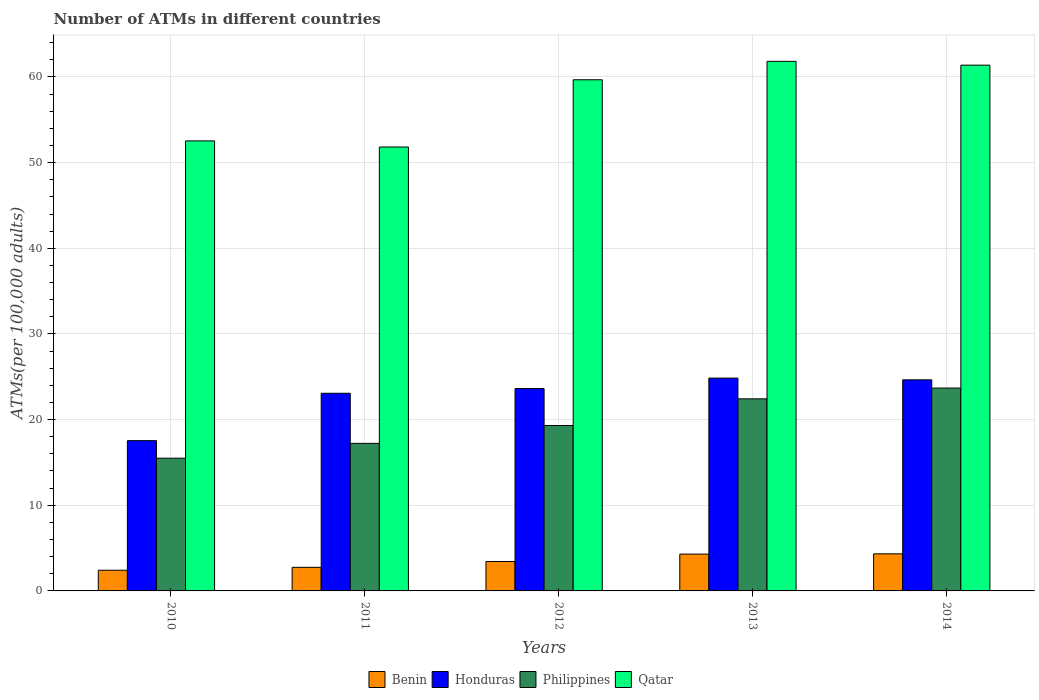How many different coloured bars are there?
Your answer should be very brief. 4. How many groups of bars are there?
Your answer should be very brief. 5. Are the number of bars per tick equal to the number of legend labels?
Give a very brief answer. Yes. How many bars are there on the 3rd tick from the right?
Make the answer very short. 4. What is the label of the 1st group of bars from the left?
Give a very brief answer. 2010. What is the number of ATMs in Honduras in 2011?
Provide a short and direct response. 23.07. Across all years, what is the maximum number of ATMs in Qatar?
Make the answer very short. 61.82. Across all years, what is the minimum number of ATMs in Benin?
Your answer should be compact. 2.42. In which year was the number of ATMs in Qatar maximum?
Your answer should be very brief. 2013. What is the total number of ATMs in Qatar in the graph?
Provide a succinct answer. 287.22. What is the difference between the number of ATMs in Benin in 2010 and that in 2013?
Offer a terse response. -1.88. What is the difference between the number of ATMs in Qatar in 2014 and the number of ATMs in Philippines in 2013?
Provide a short and direct response. 38.95. What is the average number of ATMs in Qatar per year?
Ensure brevity in your answer.  57.44. In the year 2010, what is the difference between the number of ATMs in Qatar and number of ATMs in Honduras?
Your response must be concise. 34.99. In how many years, is the number of ATMs in Honduras greater than 10?
Give a very brief answer. 5. What is the ratio of the number of ATMs in Qatar in 2010 to that in 2013?
Offer a very short reply. 0.85. What is the difference between the highest and the second highest number of ATMs in Honduras?
Provide a succinct answer. 0.2. What is the difference between the highest and the lowest number of ATMs in Honduras?
Ensure brevity in your answer.  7.3. What does the 1st bar from the left in 2012 represents?
Provide a short and direct response. Benin. What does the 1st bar from the right in 2014 represents?
Offer a very short reply. Qatar. Is it the case that in every year, the sum of the number of ATMs in Honduras and number of ATMs in Qatar is greater than the number of ATMs in Benin?
Offer a very short reply. Yes. How many bars are there?
Provide a short and direct response. 20. How many years are there in the graph?
Ensure brevity in your answer.  5. Are the values on the major ticks of Y-axis written in scientific E-notation?
Make the answer very short. No. Does the graph contain grids?
Offer a very short reply. Yes. Where does the legend appear in the graph?
Offer a terse response. Bottom center. What is the title of the graph?
Your answer should be compact. Number of ATMs in different countries. Does "Mali" appear as one of the legend labels in the graph?
Make the answer very short. No. What is the label or title of the X-axis?
Your answer should be compact. Years. What is the label or title of the Y-axis?
Your answer should be very brief. ATMs(per 100,0 adults). What is the ATMs(per 100,000 adults) in Benin in 2010?
Offer a very short reply. 2.42. What is the ATMs(per 100,000 adults) in Honduras in 2010?
Make the answer very short. 17.54. What is the ATMs(per 100,000 adults) of Philippines in 2010?
Your answer should be compact. 15.49. What is the ATMs(per 100,000 adults) in Qatar in 2010?
Give a very brief answer. 52.53. What is the ATMs(per 100,000 adults) in Benin in 2011?
Give a very brief answer. 2.75. What is the ATMs(per 100,000 adults) in Honduras in 2011?
Offer a very short reply. 23.07. What is the ATMs(per 100,000 adults) in Philippines in 2011?
Provide a succinct answer. 17.23. What is the ATMs(per 100,000 adults) of Qatar in 2011?
Your answer should be very brief. 51.82. What is the ATMs(per 100,000 adults) of Benin in 2012?
Keep it short and to the point. 3.44. What is the ATMs(per 100,000 adults) in Honduras in 2012?
Ensure brevity in your answer.  23.62. What is the ATMs(per 100,000 adults) of Philippines in 2012?
Provide a short and direct response. 19.31. What is the ATMs(per 100,000 adults) of Qatar in 2012?
Offer a very short reply. 59.67. What is the ATMs(per 100,000 adults) of Benin in 2013?
Your response must be concise. 4.3. What is the ATMs(per 100,000 adults) of Honduras in 2013?
Provide a succinct answer. 24.85. What is the ATMs(per 100,000 adults) of Philippines in 2013?
Your answer should be very brief. 22.42. What is the ATMs(per 100,000 adults) in Qatar in 2013?
Your answer should be very brief. 61.82. What is the ATMs(per 100,000 adults) of Benin in 2014?
Provide a short and direct response. 4.33. What is the ATMs(per 100,000 adults) in Honduras in 2014?
Your response must be concise. 24.64. What is the ATMs(per 100,000 adults) in Philippines in 2014?
Ensure brevity in your answer.  23.68. What is the ATMs(per 100,000 adults) of Qatar in 2014?
Offer a terse response. 61.38. Across all years, what is the maximum ATMs(per 100,000 adults) in Benin?
Ensure brevity in your answer.  4.33. Across all years, what is the maximum ATMs(per 100,000 adults) in Honduras?
Provide a short and direct response. 24.85. Across all years, what is the maximum ATMs(per 100,000 adults) in Philippines?
Keep it short and to the point. 23.68. Across all years, what is the maximum ATMs(per 100,000 adults) of Qatar?
Offer a very short reply. 61.82. Across all years, what is the minimum ATMs(per 100,000 adults) of Benin?
Your answer should be compact. 2.42. Across all years, what is the minimum ATMs(per 100,000 adults) in Honduras?
Your answer should be compact. 17.54. Across all years, what is the minimum ATMs(per 100,000 adults) of Philippines?
Your response must be concise. 15.49. Across all years, what is the minimum ATMs(per 100,000 adults) in Qatar?
Offer a terse response. 51.82. What is the total ATMs(per 100,000 adults) in Benin in the graph?
Your answer should be very brief. 17.23. What is the total ATMs(per 100,000 adults) of Honduras in the graph?
Offer a terse response. 113.72. What is the total ATMs(per 100,000 adults) in Philippines in the graph?
Give a very brief answer. 98.14. What is the total ATMs(per 100,000 adults) of Qatar in the graph?
Your answer should be very brief. 287.22. What is the difference between the ATMs(per 100,000 adults) of Benin in 2010 and that in 2011?
Provide a short and direct response. -0.34. What is the difference between the ATMs(per 100,000 adults) in Honduras in 2010 and that in 2011?
Keep it short and to the point. -5.53. What is the difference between the ATMs(per 100,000 adults) in Philippines in 2010 and that in 2011?
Give a very brief answer. -1.73. What is the difference between the ATMs(per 100,000 adults) in Qatar in 2010 and that in 2011?
Your response must be concise. 0.71. What is the difference between the ATMs(per 100,000 adults) in Benin in 2010 and that in 2012?
Give a very brief answer. -1.02. What is the difference between the ATMs(per 100,000 adults) of Honduras in 2010 and that in 2012?
Your response must be concise. -6.08. What is the difference between the ATMs(per 100,000 adults) of Philippines in 2010 and that in 2012?
Your response must be concise. -3.82. What is the difference between the ATMs(per 100,000 adults) in Qatar in 2010 and that in 2012?
Offer a very short reply. -7.13. What is the difference between the ATMs(per 100,000 adults) of Benin in 2010 and that in 2013?
Your answer should be compact. -1.88. What is the difference between the ATMs(per 100,000 adults) of Honduras in 2010 and that in 2013?
Provide a succinct answer. -7.3. What is the difference between the ATMs(per 100,000 adults) in Philippines in 2010 and that in 2013?
Your answer should be very brief. -6.93. What is the difference between the ATMs(per 100,000 adults) of Qatar in 2010 and that in 2013?
Give a very brief answer. -9.29. What is the difference between the ATMs(per 100,000 adults) in Benin in 2010 and that in 2014?
Keep it short and to the point. -1.91. What is the difference between the ATMs(per 100,000 adults) in Honduras in 2010 and that in 2014?
Make the answer very short. -7.1. What is the difference between the ATMs(per 100,000 adults) of Philippines in 2010 and that in 2014?
Offer a very short reply. -8.19. What is the difference between the ATMs(per 100,000 adults) of Qatar in 2010 and that in 2014?
Ensure brevity in your answer.  -8.84. What is the difference between the ATMs(per 100,000 adults) of Benin in 2011 and that in 2012?
Offer a very short reply. -0.68. What is the difference between the ATMs(per 100,000 adults) of Honduras in 2011 and that in 2012?
Your response must be concise. -0.55. What is the difference between the ATMs(per 100,000 adults) of Philippines in 2011 and that in 2012?
Make the answer very short. -2.08. What is the difference between the ATMs(per 100,000 adults) in Qatar in 2011 and that in 2012?
Make the answer very short. -7.85. What is the difference between the ATMs(per 100,000 adults) of Benin in 2011 and that in 2013?
Keep it short and to the point. -1.54. What is the difference between the ATMs(per 100,000 adults) of Honduras in 2011 and that in 2013?
Provide a succinct answer. -1.77. What is the difference between the ATMs(per 100,000 adults) in Philippines in 2011 and that in 2013?
Offer a terse response. -5.2. What is the difference between the ATMs(per 100,000 adults) in Qatar in 2011 and that in 2013?
Provide a succinct answer. -10. What is the difference between the ATMs(per 100,000 adults) in Benin in 2011 and that in 2014?
Make the answer very short. -1.58. What is the difference between the ATMs(per 100,000 adults) in Honduras in 2011 and that in 2014?
Your answer should be compact. -1.57. What is the difference between the ATMs(per 100,000 adults) in Philippines in 2011 and that in 2014?
Give a very brief answer. -6.45. What is the difference between the ATMs(per 100,000 adults) in Qatar in 2011 and that in 2014?
Offer a very short reply. -9.56. What is the difference between the ATMs(per 100,000 adults) of Benin in 2012 and that in 2013?
Provide a succinct answer. -0.86. What is the difference between the ATMs(per 100,000 adults) in Honduras in 2012 and that in 2013?
Your answer should be compact. -1.22. What is the difference between the ATMs(per 100,000 adults) in Philippines in 2012 and that in 2013?
Ensure brevity in your answer.  -3.11. What is the difference between the ATMs(per 100,000 adults) in Qatar in 2012 and that in 2013?
Your answer should be very brief. -2.15. What is the difference between the ATMs(per 100,000 adults) in Benin in 2012 and that in 2014?
Your answer should be compact. -0.89. What is the difference between the ATMs(per 100,000 adults) of Honduras in 2012 and that in 2014?
Your answer should be very brief. -1.02. What is the difference between the ATMs(per 100,000 adults) of Philippines in 2012 and that in 2014?
Offer a very short reply. -4.37. What is the difference between the ATMs(per 100,000 adults) of Qatar in 2012 and that in 2014?
Offer a very short reply. -1.71. What is the difference between the ATMs(per 100,000 adults) in Benin in 2013 and that in 2014?
Offer a terse response. -0.03. What is the difference between the ATMs(per 100,000 adults) in Honduras in 2013 and that in 2014?
Ensure brevity in your answer.  0.2. What is the difference between the ATMs(per 100,000 adults) in Philippines in 2013 and that in 2014?
Your answer should be compact. -1.26. What is the difference between the ATMs(per 100,000 adults) in Qatar in 2013 and that in 2014?
Provide a short and direct response. 0.44. What is the difference between the ATMs(per 100,000 adults) in Benin in 2010 and the ATMs(per 100,000 adults) in Honduras in 2011?
Keep it short and to the point. -20.66. What is the difference between the ATMs(per 100,000 adults) of Benin in 2010 and the ATMs(per 100,000 adults) of Philippines in 2011?
Offer a very short reply. -14.81. What is the difference between the ATMs(per 100,000 adults) of Benin in 2010 and the ATMs(per 100,000 adults) of Qatar in 2011?
Keep it short and to the point. -49.4. What is the difference between the ATMs(per 100,000 adults) in Honduras in 2010 and the ATMs(per 100,000 adults) in Philippines in 2011?
Offer a very short reply. 0.31. What is the difference between the ATMs(per 100,000 adults) in Honduras in 2010 and the ATMs(per 100,000 adults) in Qatar in 2011?
Ensure brevity in your answer.  -34.28. What is the difference between the ATMs(per 100,000 adults) in Philippines in 2010 and the ATMs(per 100,000 adults) in Qatar in 2011?
Your answer should be compact. -36.33. What is the difference between the ATMs(per 100,000 adults) of Benin in 2010 and the ATMs(per 100,000 adults) of Honduras in 2012?
Your answer should be compact. -21.2. What is the difference between the ATMs(per 100,000 adults) in Benin in 2010 and the ATMs(per 100,000 adults) in Philippines in 2012?
Provide a succinct answer. -16.89. What is the difference between the ATMs(per 100,000 adults) of Benin in 2010 and the ATMs(per 100,000 adults) of Qatar in 2012?
Give a very brief answer. -57.25. What is the difference between the ATMs(per 100,000 adults) in Honduras in 2010 and the ATMs(per 100,000 adults) in Philippines in 2012?
Provide a short and direct response. -1.77. What is the difference between the ATMs(per 100,000 adults) in Honduras in 2010 and the ATMs(per 100,000 adults) in Qatar in 2012?
Give a very brief answer. -42.13. What is the difference between the ATMs(per 100,000 adults) of Philippines in 2010 and the ATMs(per 100,000 adults) of Qatar in 2012?
Provide a succinct answer. -44.17. What is the difference between the ATMs(per 100,000 adults) of Benin in 2010 and the ATMs(per 100,000 adults) of Honduras in 2013?
Make the answer very short. -22.43. What is the difference between the ATMs(per 100,000 adults) of Benin in 2010 and the ATMs(per 100,000 adults) of Philippines in 2013?
Provide a short and direct response. -20.01. What is the difference between the ATMs(per 100,000 adults) in Benin in 2010 and the ATMs(per 100,000 adults) in Qatar in 2013?
Keep it short and to the point. -59.4. What is the difference between the ATMs(per 100,000 adults) of Honduras in 2010 and the ATMs(per 100,000 adults) of Philippines in 2013?
Make the answer very short. -4.88. What is the difference between the ATMs(per 100,000 adults) of Honduras in 2010 and the ATMs(per 100,000 adults) of Qatar in 2013?
Provide a short and direct response. -44.28. What is the difference between the ATMs(per 100,000 adults) in Philippines in 2010 and the ATMs(per 100,000 adults) in Qatar in 2013?
Keep it short and to the point. -46.33. What is the difference between the ATMs(per 100,000 adults) of Benin in 2010 and the ATMs(per 100,000 adults) of Honduras in 2014?
Your answer should be very brief. -22.22. What is the difference between the ATMs(per 100,000 adults) in Benin in 2010 and the ATMs(per 100,000 adults) in Philippines in 2014?
Ensure brevity in your answer.  -21.27. What is the difference between the ATMs(per 100,000 adults) of Benin in 2010 and the ATMs(per 100,000 adults) of Qatar in 2014?
Keep it short and to the point. -58.96. What is the difference between the ATMs(per 100,000 adults) of Honduras in 2010 and the ATMs(per 100,000 adults) of Philippines in 2014?
Your response must be concise. -6.14. What is the difference between the ATMs(per 100,000 adults) of Honduras in 2010 and the ATMs(per 100,000 adults) of Qatar in 2014?
Your answer should be very brief. -43.83. What is the difference between the ATMs(per 100,000 adults) in Philippines in 2010 and the ATMs(per 100,000 adults) in Qatar in 2014?
Your answer should be very brief. -45.88. What is the difference between the ATMs(per 100,000 adults) in Benin in 2011 and the ATMs(per 100,000 adults) in Honduras in 2012?
Offer a very short reply. -20.87. What is the difference between the ATMs(per 100,000 adults) of Benin in 2011 and the ATMs(per 100,000 adults) of Philippines in 2012?
Your answer should be very brief. -16.56. What is the difference between the ATMs(per 100,000 adults) in Benin in 2011 and the ATMs(per 100,000 adults) in Qatar in 2012?
Provide a short and direct response. -56.91. What is the difference between the ATMs(per 100,000 adults) in Honduras in 2011 and the ATMs(per 100,000 adults) in Philippines in 2012?
Make the answer very short. 3.76. What is the difference between the ATMs(per 100,000 adults) in Honduras in 2011 and the ATMs(per 100,000 adults) in Qatar in 2012?
Ensure brevity in your answer.  -36.6. What is the difference between the ATMs(per 100,000 adults) in Philippines in 2011 and the ATMs(per 100,000 adults) in Qatar in 2012?
Provide a short and direct response. -42.44. What is the difference between the ATMs(per 100,000 adults) in Benin in 2011 and the ATMs(per 100,000 adults) in Honduras in 2013?
Offer a very short reply. -22.09. What is the difference between the ATMs(per 100,000 adults) in Benin in 2011 and the ATMs(per 100,000 adults) in Philippines in 2013?
Keep it short and to the point. -19.67. What is the difference between the ATMs(per 100,000 adults) of Benin in 2011 and the ATMs(per 100,000 adults) of Qatar in 2013?
Make the answer very short. -59.07. What is the difference between the ATMs(per 100,000 adults) in Honduras in 2011 and the ATMs(per 100,000 adults) in Philippines in 2013?
Give a very brief answer. 0.65. What is the difference between the ATMs(per 100,000 adults) of Honduras in 2011 and the ATMs(per 100,000 adults) of Qatar in 2013?
Your answer should be compact. -38.75. What is the difference between the ATMs(per 100,000 adults) in Philippines in 2011 and the ATMs(per 100,000 adults) in Qatar in 2013?
Your response must be concise. -44.59. What is the difference between the ATMs(per 100,000 adults) in Benin in 2011 and the ATMs(per 100,000 adults) in Honduras in 2014?
Your response must be concise. -21.89. What is the difference between the ATMs(per 100,000 adults) in Benin in 2011 and the ATMs(per 100,000 adults) in Philippines in 2014?
Offer a very short reply. -20.93. What is the difference between the ATMs(per 100,000 adults) in Benin in 2011 and the ATMs(per 100,000 adults) in Qatar in 2014?
Your answer should be compact. -58.62. What is the difference between the ATMs(per 100,000 adults) of Honduras in 2011 and the ATMs(per 100,000 adults) of Philippines in 2014?
Keep it short and to the point. -0.61. What is the difference between the ATMs(per 100,000 adults) of Honduras in 2011 and the ATMs(per 100,000 adults) of Qatar in 2014?
Offer a very short reply. -38.3. What is the difference between the ATMs(per 100,000 adults) in Philippines in 2011 and the ATMs(per 100,000 adults) in Qatar in 2014?
Your response must be concise. -44.15. What is the difference between the ATMs(per 100,000 adults) of Benin in 2012 and the ATMs(per 100,000 adults) of Honduras in 2013?
Your response must be concise. -21.41. What is the difference between the ATMs(per 100,000 adults) of Benin in 2012 and the ATMs(per 100,000 adults) of Philippines in 2013?
Make the answer very short. -18.99. What is the difference between the ATMs(per 100,000 adults) of Benin in 2012 and the ATMs(per 100,000 adults) of Qatar in 2013?
Make the answer very short. -58.38. What is the difference between the ATMs(per 100,000 adults) of Honduras in 2012 and the ATMs(per 100,000 adults) of Philippines in 2013?
Keep it short and to the point. 1.2. What is the difference between the ATMs(per 100,000 adults) in Honduras in 2012 and the ATMs(per 100,000 adults) in Qatar in 2013?
Provide a succinct answer. -38.2. What is the difference between the ATMs(per 100,000 adults) of Philippines in 2012 and the ATMs(per 100,000 adults) of Qatar in 2013?
Provide a succinct answer. -42.51. What is the difference between the ATMs(per 100,000 adults) in Benin in 2012 and the ATMs(per 100,000 adults) in Honduras in 2014?
Keep it short and to the point. -21.2. What is the difference between the ATMs(per 100,000 adults) of Benin in 2012 and the ATMs(per 100,000 adults) of Philippines in 2014?
Make the answer very short. -20.25. What is the difference between the ATMs(per 100,000 adults) in Benin in 2012 and the ATMs(per 100,000 adults) in Qatar in 2014?
Your answer should be compact. -57.94. What is the difference between the ATMs(per 100,000 adults) in Honduras in 2012 and the ATMs(per 100,000 adults) in Philippines in 2014?
Your answer should be very brief. -0.06. What is the difference between the ATMs(per 100,000 adults) in Honduras in 2012 and the ATMs(per 100,000 adults) in Qatar in 2014?
Ensure brevity in your answer.  -37.76. What is the difference between the ATMs(per 100,000 adults) of Philippines in 2012 and the ATMs(per 100,000 adults) of Qatar in 2014?
Give a very brief answer. -42.07. What is the difference between the ATMs(per 100,000 adults) of Benin in 2013 and the ATMs(per 100,000 adults) of Honduras in 2014?
Provide a succinct answer. -20.34. What is the difference between the ATMs(per 100,000 adults) in Benin in 2013 and the ATMs(per 100,000 adults) in Philippines in 2014?
Offer a terse response. -19.38. What is the difference between the ATMs(per 100,000 adults) of Benin in 2013 and the ATMs(per 100,000 adults) of Qatar in 2014?
Provide a succinct answer. -57.08. What is the difference between the ATMs(per 100,000 adults) in Honduras in 2013 and the ATMs(per 100,000 adults) in Philippines in 2014?
Provide a succinct answer. 1.16. What is the difference between the ATMs(per 100,000 adults) of Honduras in 2013 and the ATMs(per 100,000 adults) of Qatar in 2014?
Your response must be concise. -36.53. What is the difference between the ATMs(per 100,000 adults) of Philippines in 2013 and the ATMs(per 100,000 adults) of Qatar in 2014?
Keep it short and to the point. -38.95. What is the average ATMs(per 100,000 adults) of Benin per year?
Provide a short and direct response. 3.45. What is the average ATMs(per 100,000 adults) in Honduras per year?
Provide a short and direct response. 22.74. What is the average ATMs(per 100,000 adults) in Philippines per year?
Your answer should be very brief. 19.63. What is the average ATMs(per 100,000 adults) in Qatar per year?
Give a very brief answer. 57.44. In the year 2010, what is the difference between the ATMs(per 100,000 adults) of Benin and ATMs(per 100,000 adults) of Honduras?
Your answer should be compact. -15.13. In the year 2010, what is the difference between the ATMs(per 100,000 adults) of Benin and ATMs(per 100,000 adults) of Philippines?
Give a very brief answer. -13.08. In the year 2010, what is the difference between the ATMs(per 100,000 adults) of Benin and ATMs(per 100,000 adults) of Qatar?
Provide a succinct answer. -50.12. In the year 2010, what is the difference between the ATMs(per 100,000 adults) of Honduras and ATMs(per 100,000 adults) of Philippines?
Provide a short and direct response. 2.05. In the year 2010, what is the difference between the ATMs(per 100,000 adults) in Honduras and ATMs(per 100,000 adults) in Qatar?
Your answer should be compact. -34.99. In the year 2010, what is the difference between the ATMs(per 100,000 adults) of Philippines and ATMs(per 100,000 adults) of Qatar?
Your answer should be compact. -37.04. In the year 2011, what is the difference between the ATMs(per 100,000 adults) of Benin and ATMs(per 100,000 adults) of Honduras?
Your answer should be compact. -20.32. In the year 2011, what is the difference between the ATMs(per 100,000 adults) in Benin and ATMs(per 100,000 adults) in Philippines?
Offer a terse response. -14.47. In the year 2011, what is the difference between the ATMs(per 100,000 adults) of Benin and ATMs(per 100,000 adults) of Qatar?
Your response must be concise. -49.07. In the year 2011, what is the difference between the ATMs(per 100,000 adults) in Honduras and ATMs(per 100,000 adults) in Philippines?
Provide a short and direct response. 5.85. In the year 2011, what is the difference between the ATMs(per 100,000 adults) of Honduras and ATMs(per 100,000 adults) of Qatar?
Ensure brevity in your answer.  -28.75. In the year 2011, what is the difference between the ATMs(per 100,000 adults) in Philippines and ATMs(per 100,000 adults) in Qatar?
Your response must be concise. -34.59. In the year 2012, what is the difference between the ATMs(per 100,000 adults) in Benin and ATMs(per 100,000 adults) in Honduras?
Make the answer very short. -20.19. In the year 2012, what is the difference between the ATMs(per 100,000 adults) in Benin and ATMs(per 100,000 adults) in Philippines?
Ensure brevity in your answer.  -15.87. In the year 2012, what is the difference between the ATMs(per 100,000 adults) in Benin and ATMs(per 100,000 adults) in Qatar?
Your response must be concise. -56.23. In the year 2012, what is the difference between the ATMs(per 100,000 adults) in Honduras and ATMs(per 100,000 adults) in Philippines?
Ensure brevity in your answer.  4.31. In the year 2012, what is the difference between the ATMs(per 100,000 adults) in Honduras and ATMs(per 100,000 adults) in Qatar?
Provide a short and direct response. -36.05. In the year 2012, what is the difference between the ATMs(per 100,000 adults) in Philippines and ATMs(per 100,000 adults) in Qatar?
Provide a succinct answer. -40.36. In the year 2013, what is the difference between the ATMs(per 100,000 adults) of Benin and ATMs(per 100,000 adults) of Honduras?
Provide a succinct answer. -20.55. In the year 2013, what is the difference between the ATMs(per 100,000 adults) in Benin and ATMs(per 100,000 adults) in Philippines?
Offer a terse response. -18.12. In the year 2013, what is the difference between the ATMs(per 100,000 adults) of Benin and ATMs(per 100,000 adults) of Qatar?
Provide a succinct answer. -57.52. In the year 2013, what is the difference between the ATMs(per 100,000 adults) of Honduras and ATMs(per 100,000 adults) of Philippines?
Your response must be concise. 2.42. In the year 2013, what is the difference between the ATMs(per 100,000 adults) in Honduras and ATMs(per 100,000 adults) in Qatar?
Your answer should be compact. -36.97. In the year 2013, what is the difference between the ATMs(per 100,000 adults) in Philippines and ATMs(per 100,000 adults) in Qatar?
Your response must be concise. -39.4. In the year 2014, what is the difference between the ATMs(per 100,000 adults) in Benin and ATMs(per 100,000 adults) in Honduras?
Give a very brief answer. -20.31. In the year 2014, what is the difference between the ATMs(per 100,000 adults) in Benin and ATMs(per 100,000 adults) in Philippines?
Provide a succinct answer. -19.35. In the year 2014, what is the difference between the ATMs(per 100,000 adults) in Benin and ATMs(per 100,000 adults) in Qatar?
Make the answer very short. -57.05. In the year 2014, what is the difference between the ATMs(per 100,000 adults) in Honduras and ATMs(per 100,000 adults) in Philippines?
Provide a short and direct response. 0.96. In the year 2014, what is the difference between the ATMs(per 100,000 adults) of Honduras and ATMs(per 100,000 adults) of Qatar?
Give a very brief answer. -36.74. In the year 2014, what is the difference between the ATMs(per 100,000 adults) of Philippines and ATMs(per 100,000 adults) of Qatar?
Your answer should be compact. -37.7. What is the ratio of the ATMs(per 100,000 adults) of Benin in 2010 to that in 2011?
Give a very brief answer. 0.88. What is the ratio of the ATMs(per 100,000 adults) in Honduras in 2010 to that in 2011?
Provide a succinct answer. 0.76. What is the ratio of the ATMs(per 100,000 adults) in Philippines in 2010 to that in 2011?
Make the answer very short. 0.9. What is the ratio of the ATMs(per 100,000 adults) of Qatar in 2010 to that in 2011?
Ensure brevity in your answer.  1.01. What is the ratio of the ATMs(per 100,000 adults) in Benin in 2010 to that in 2012?
Your response must be concise. 0.7. What is the ratio of the ATMs(per 100,000 adults) of Honduras in 2010 to that in 2012?
Offer a terse response. 0.74. What is the ratio of the ATMs(per 100,000 adults) of Philippines in 2010 to that in 2012?
Offer a very short reply. 0.8. What is the ratio of the ATMs(per 100,000 adults) of Qatar in 2010 to that in 2012?
Ensure brevity in your answer.  0.88. What is the ratio of the ATMs(per 100,000 adults) in Benin in 2010 to that in 2013?
Give a very brief answer. 0.56. What is the ratio of the ATMs(per 100,000 adults) in Honduras in 2010 to that in 2013?
Ensure brevity in your answer.  0.71. What is the ratio of the ATMs(per 100,000 adults) of Philippines in 2010 to that in 2013?
Your answer should be very brief. 0.69. What is the ratio of the ATMs(per 100,000 adults) of Qatar in 2010 to that in 2013?
Your answer should be very brief. 0.85. What is the ratio of the ATMs(per 100,000 adults) in Benin in 2010 to that in 2014?
Offer a terse response. 0.56. What is the ratio of the ATMs(per 100,000 adults) of Honduras in 2010 to that in 2014?
Keep it short and to the point. 0.71. What is the ratio of the ATMs(per 100,000 adults) of Philippines in 2010 to that in 2014?
Offer a very short reply. 0.65. What is the ratio of the ATMs(per 100,000 adults) in Qatar in 2010 to that in 2014?
Offer a very short reply. 0.86. What is the ratio of the ATMs(per 100,000 adults) in Benin in 2011 to that in 2012?
Provide a short and direct response. 0.8. What is the ratio of the ATMs(per 100,000 adults) in Honduras in 2011 to that in 2012?
Give a very brief answer. 0.98. What is the ratio of the ATMs(per 100,000 adults) in Philippines in 2011 to that in 2012?
Your answer should be compact. 0.89. What is the ratio of the ATMs(per 100,000 adults) in Qatar in 2011 to that in 2012?
Ensure brevity in your answer.  0.87. What is the ratio of the ATMs(per 100,000 adults) in Benin in 2011 to that in 2013?
Offer a very short reply. 0.64. What is the ratio of the ATMs(per 100,000 adults) of Honduras in 2011 to that in 2013?
Provide a short and direct response. 0.93. What is the ratio of the ATMs(per 100,000 adults) of Philippines in 2011 to that in 2013?
Ensure brevity in your answer.  0.77. What is the ratio of the ATMs(per 100,000 adults) in Qatar in 2011 to that in 2013?
Offer a terse response. 0.84. What is the ratio of the ATMs(per 100,000 adults) in Benin in 2011 to that in 2014?
Give a very brief answer. 0.64. What is the ratio of the ATMs(per 100,000 adults) in Honduras in 2011 to that in 2014?
Your answer should be very brief. 0.94. What is the ratio of the ATMs(per 100,000 adults) in Philippines in 2011 to that in 2014?
Your response must be concise. 0.73. What is the ratio of the ATMs(per 100,000 adults) of Qatar in 2011 to that in 2014?
Offer a terse response. 0.84. What is the ratio of the ATMs(per 100,000 adults) in Benin in 2012 to that in 2013?
Offer a very short reply. 0.8. What is the ratio of the ATMs(per 100,000 adults) in Honduras in 2012 to that in 2013?
Keep it short and to the point. 0.95. What is the ratio of the ATMs(per 100,000 adults) of Philippines in 2012 to that in 2013?
Provide a succinct answer. 0.86. What is the ratio of the ATMs(per 100,000 adults) in Qatar in 2012 to that in 2013?
Ensure brevity in your answer.  0.97. What is the ratio of the ATMs(per 100,000 adults) of Benin in 2012 to that in 2014?
Offer a terse response. 0.79. What is the ratio of the ATMs(per 100,000 adults) in Honduras in 2012 to that in 2014?
Offer a very short reply. 0.96. What is the ratio of the ATMs(per 100,000 adults) of Philippines in 2012 to that in 2014?
Give a very brief answer. 0.82. What is the ratio of the ATMs(per 100,000 adults) in Qatar in 2012 to that in 2014?
Ensure brevity in your answer.  0.97. What is the ratio of the ATMs(per 100,000 adults) in Benin in 2013 to that in 2014?
Your response must be concise. 0.99. What is the ratio of the ATMs(per 100,000 adults) of Honduras in 2013 to that in 2014?
Keep it short and to the point. 1.01. What is the ratio of the ATMs(per 100,000 adults) in Philippines in 2013 to that in 2014?
Ensure brevity in your answer.  0.95. What is the difference between the highest and the second highest ATMs(per 100,000 adults) of Benin?
Make the answer very short. 0.03. What is the difference between the highest and the second highest ATMs(per 100,000 adults) of Honduras?
Your answer should be compact. 0.2. What is the difference between the highest and the second highest ATMs(per 100,000 adults) of Philippines?
Provide a succinct answer. 1.26. What is the difference between the highest and the second highest ATMs(per 100,000 adults) in Qatar?
Your response must be concise. 0.44. What is the difference between the highest and the lowest ATMs(per 100,000 adults) of Benin?
Give a very brief answer. 1.91. What is the difference between the highest and the lowest ATMs(per 100,000 adults) in Honduras?
Make the answer very short. 7.3. What is the difference between the highest and the lowest ATMs(per 100,000 adults) of Philippines?
Provide a short and direct response. 8.19. What is the difference between the highest and the lowest ATMs(per 100,000 adults) of Qatar?
Offer a terse response. 10. 